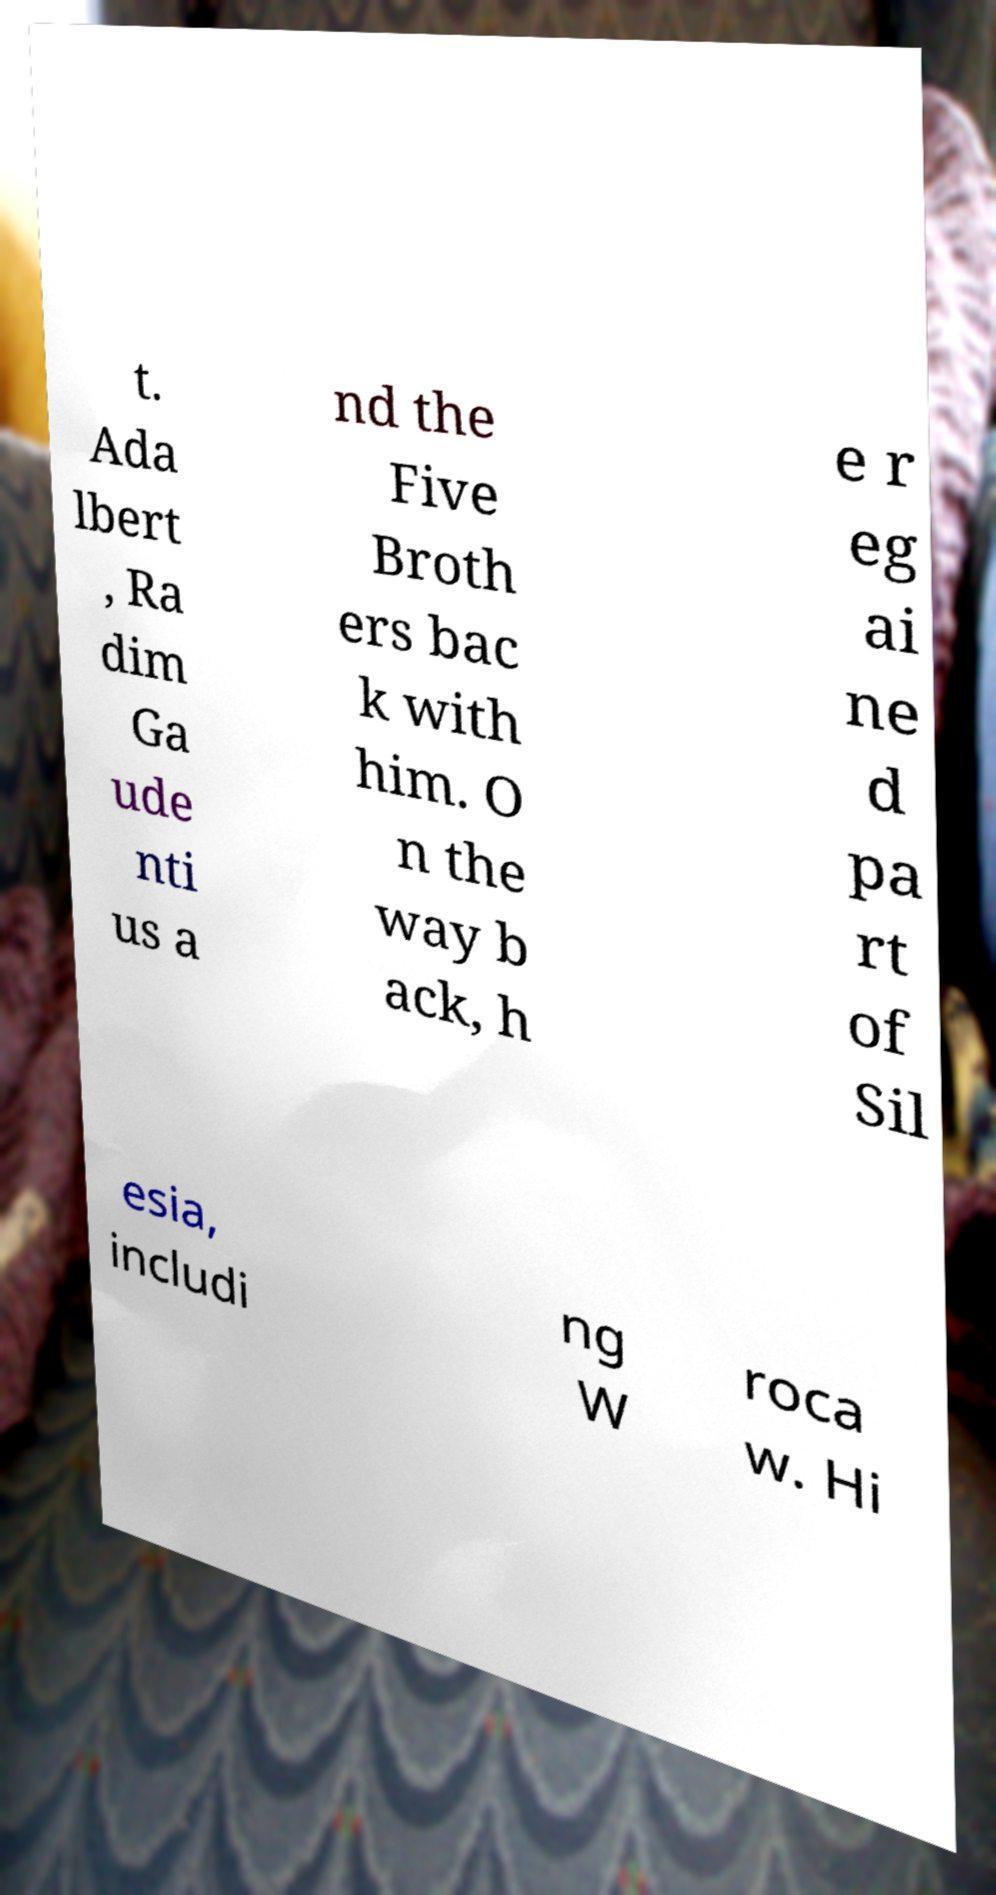Could you extract and type out the text from this image? t. Ada lbert , Ra dim Ga ude nti us a nd the Five Broth ers bac k with him. O n the way b ack, h e r eg ai ne d pa rt of Sil esia, includi ng W roca w. Hi 